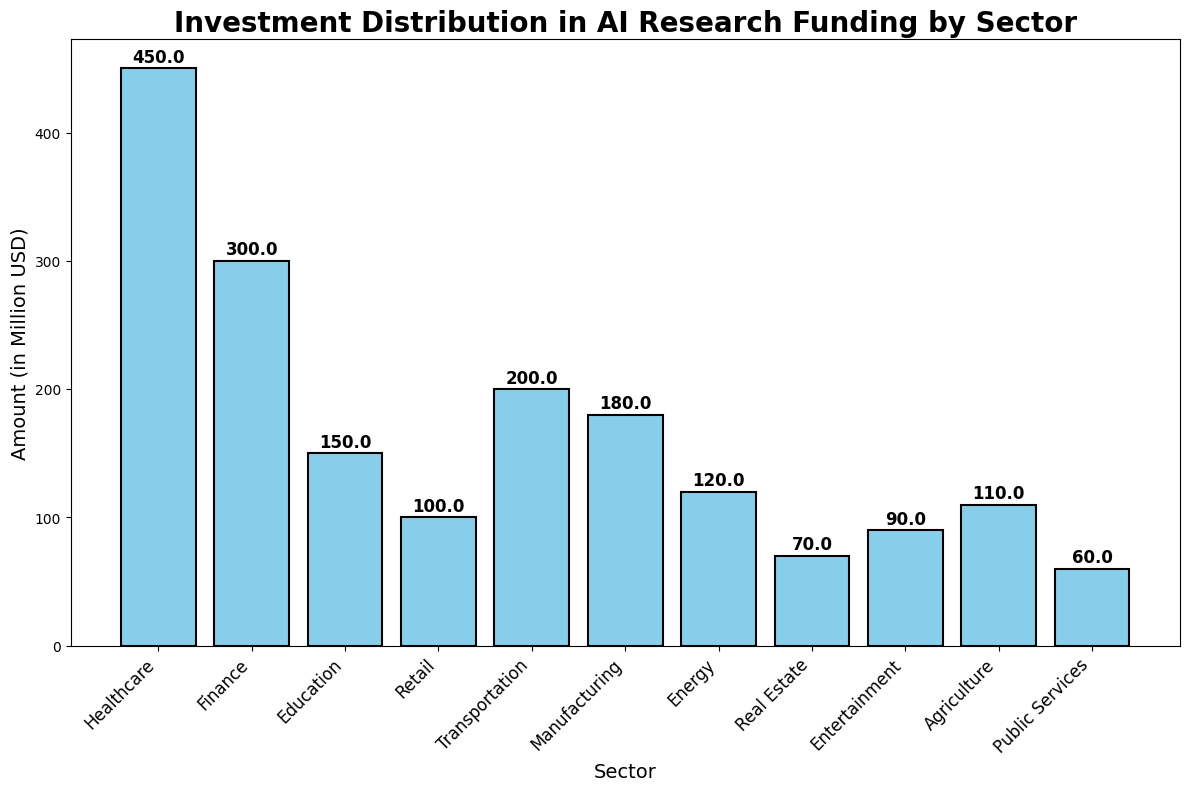Which sector received the highest investment? Look at the bar chart and identify the bar with the greatest height, which represents the sector with the highest investment.
Answer: Healthcare Which sector received the lowest investment? Identify the bar with the smallest height, which corresponds to the sector with the lowest investment amount.
Answer: Public Services How much more investment did Healthcare receive compared to Finance? Find the heights for the bars representing Healthcare and Finance. The Healthcare bar height is 450 million USD, and the Finance bar height is 300 million USD. Subtract Finance's investment from Healthcare's investment: 450 - 300 = 150 million USD.
Answer: 150 million USD What is the combined investment for Education and Manufacturing sectors? Look at the bar heights for Education and Manufacturing. The investments are 150 and 180 million USD respectively. Add these values together: 150 + 180 = 330 million USD.
Answer: 330 million USD Which sectors received more than 200 million USD in investment? Identify the bars with heights greater than 200 million USD. The sectors are Healthcare (450 million USD) and Finance (300 million USD).
Answer: Healthcare and Finance Compare the investments in Retail and Transportation. Which one received more, and by how much? Look at the heights of the bars for Retail and Transportation. Retail has 100 million USD, and Transportation has 200 million USD. Transportation received more by 100 million USD (200 - 100).
Answer: Transportation by 100 million USD What is the average investment amount across all sectors? Sum all investment amounts and divide by the number of sectors. The total investment is 450 + 300 + 150 + 100 + 200 + 180 + 120 + 70 + 90 + 110 + 60 = 1830 million USD. There are 11 sectors, so the average investment is 1830 / 11 = 166.36 million USD.
Answer: 166.36 million USD Which sector has an investment amount closest to the average investment amount? The calculated average investment amount is 166.36 million USD. From the data, Education received 150 million USD, and Manufacturing received 180 million USD. The sector closest to the average is Education (150 million USD).
Answer: Education What is the total amount invested in sectors that received less than 100 million USD individually? Identify the sectors with investments below 100 million USD: Public Services (60 million), Real Estate (70 million), and Entertainment (90 million). Sum these amounts: 60 + 70 + 90 = 220 million USD.
Answer: 220 million USD 